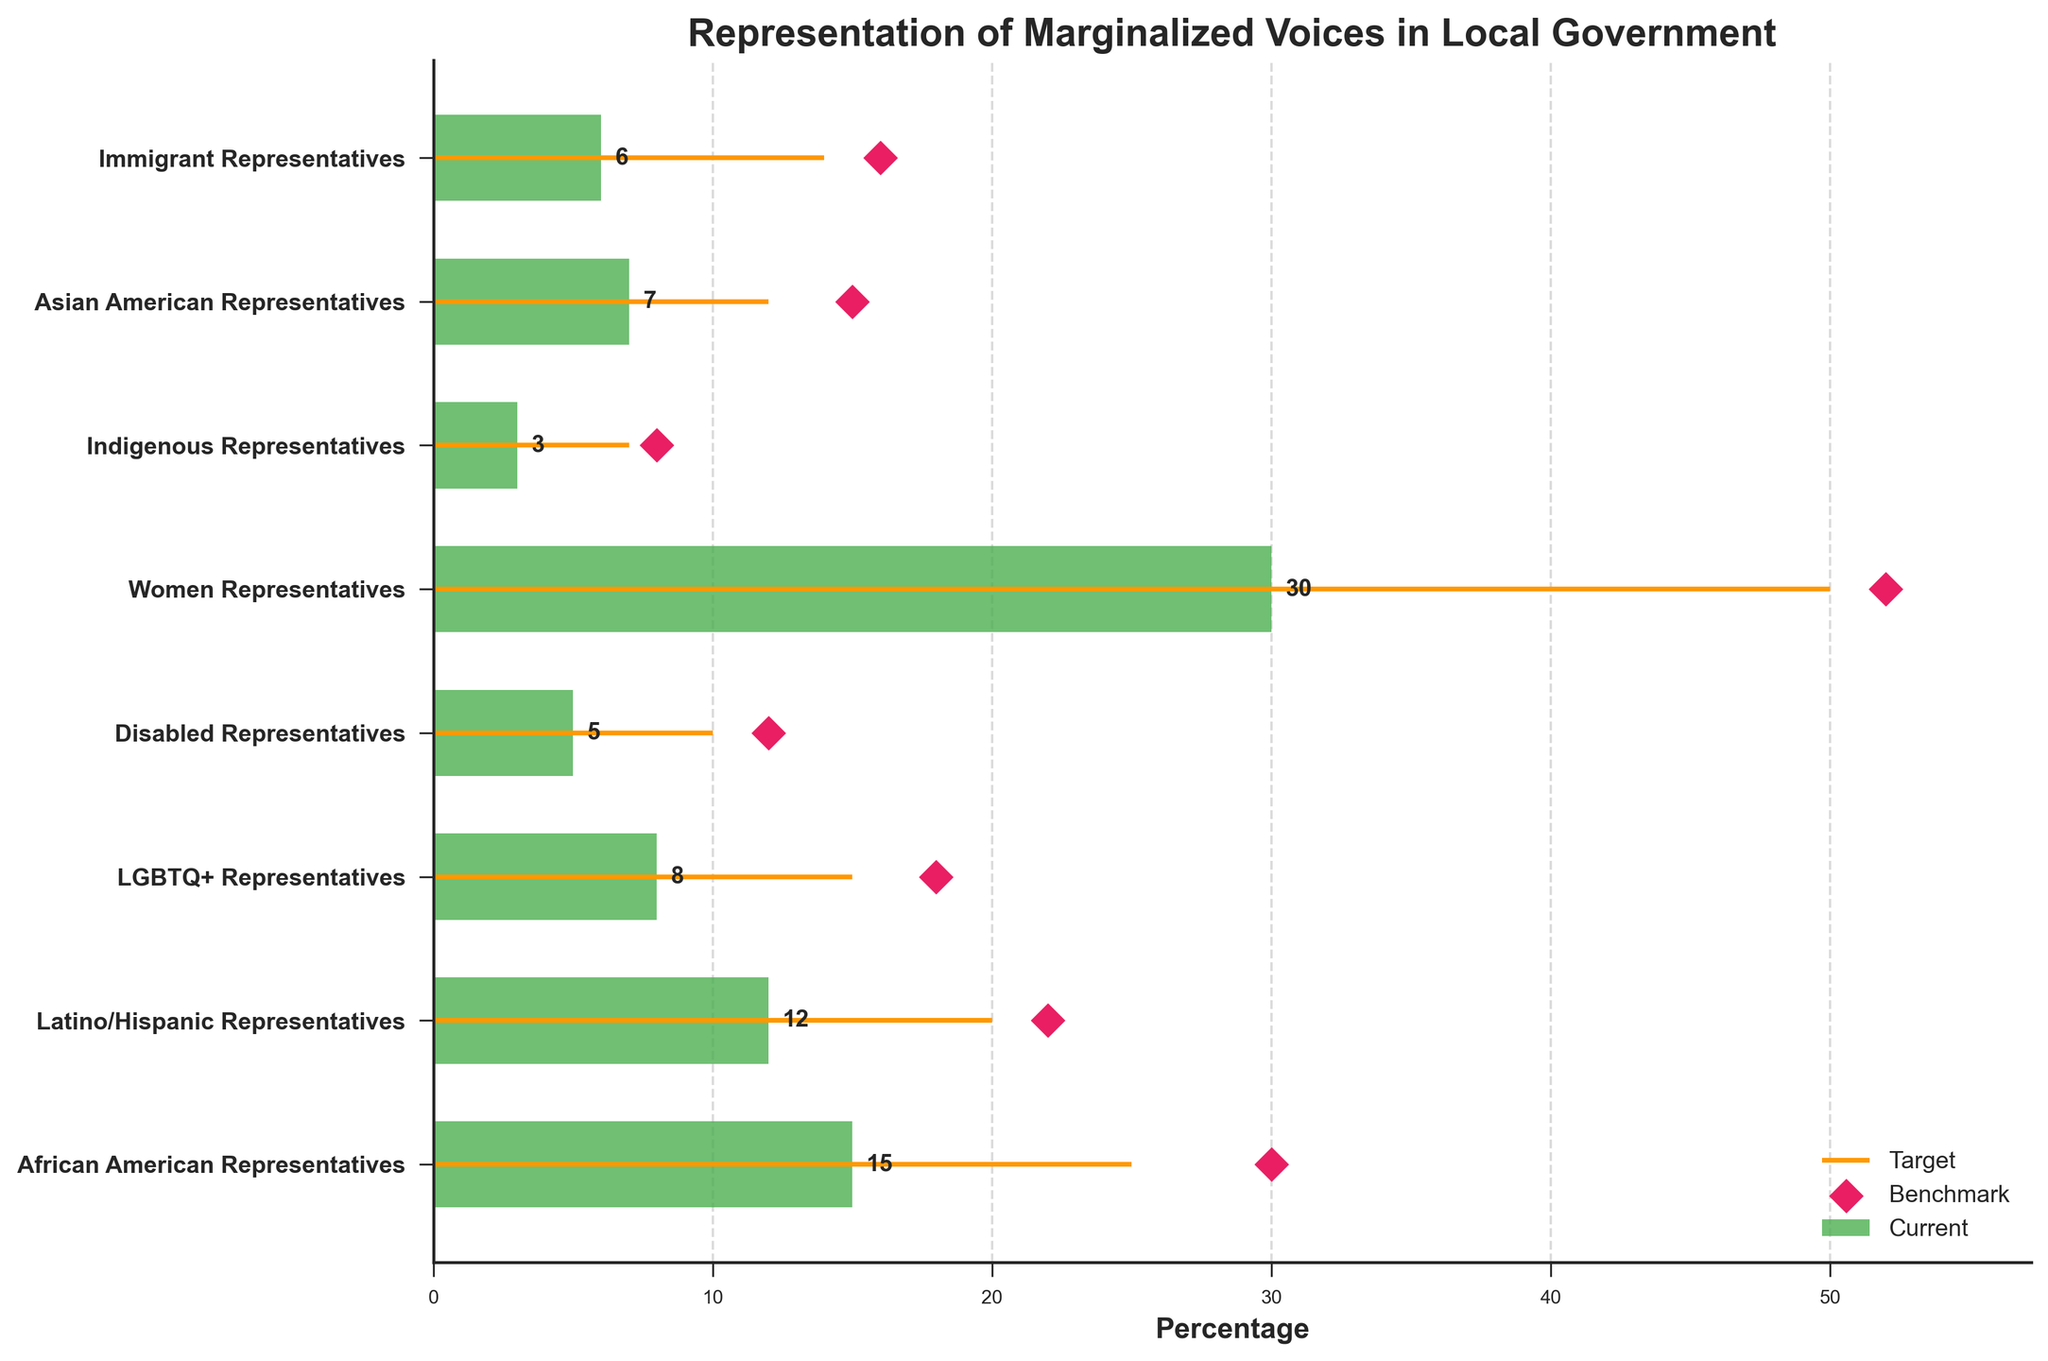what is the current percentage of African American Representatives in local government? The figure shows that the current percentage for African American Representatives is represented by a horizontal green bar. The value labeled at the end of this bar is the current percentage.
Answer: 15 what is the discrepancy between the target and benchmark percentage for Indigenous Representatives? First, identify the target percentage for Indigenous Representatives and the benchmark percentage. The target is noted by the orange line, and the benchmark by the pink diamond. Subtract the target from the benchmark to find the discrepancy.
Answer: 1 Which group has the smallest current representation relative to the benchmark? Check all the current percentages against their respective benchmark percentages. The group with the largest difference between current and benchmark has the smallest relative representation.
Answer: Indigenous Representatives what is the current and target percentage for LGBTQ+ Representatives? Look for the horizontal green bar (current) and the orange line (target) for LGBTQ+ Representatives. The values labeled at these points represent the current and target percentages respectively.
Answer: Current: 8, Target: 15 How many percentage points are Women Representatives short of reaching their target? Look at the current percentage and the target percentage for Women Representatives. Subtract the current percentage from the target percentage to find the points remaining to reach the target.
Answer: 20 what's the overall trend between current and target percentages across all categories? By examining the positions of the green bars (current) and comparing them to the orange lines (target) across all categories, assess whether current percentages generally fall below or close to the target percentages.
Answer: Generally below which category currently meets or exceeds the benchmark set for representation? Compare the end of the green bars (current) with the pink diamonds (benchmark) to check which, if any, current percentages are at or above their benchmarks.
Answer: None what’s the difference between the highest and lowest current representation? Find the highest and lowest values from the current representation (green bars). Subtract to find the difference between these percentages. The highest current is Women Representatives (30) and the lowest is Indigenous Representatives (3).
Answer: 27 which groups have a target that is less ambitious than their benchmark? For each group, compare the target percentage (orange line) to the benchmark (pink diamond). Note which targets are lower than the benchmarks.
Answer: Latino/Hispanic Representatives, Disabled Representatives, Asian American Representatives, Immigrant Representatives 